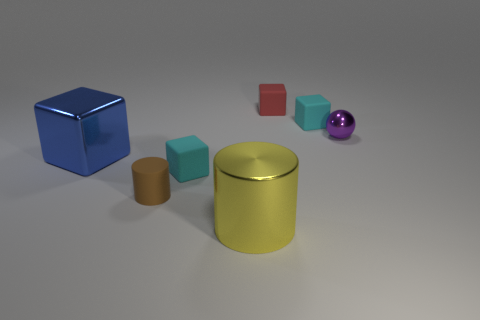Subtract all tiny red matte blocks. How many blocks are left? 3 Add 2 brown cubes. How many objects exist? 9 Subtract all brown cylinders. How many cylinders are left? 1 Subtract 4 blocks. How many blocks are left? 0 Add 1 small cyan shiny cylinders. How many small cyan shiny cylinders exist? 1 Subtract 0 red cylinders. How many objects are left? 7 Subtract all blocks. How many objects are left? 3 Subtract all red balls. Subtract all cyan cylinders. How many balls are left? 1 Subtract all green blocks. How many brown cylinders are left? 1 Subtract all big cyan rubber cubes. Subtract all small shiny objects. How many objects are left? 6 